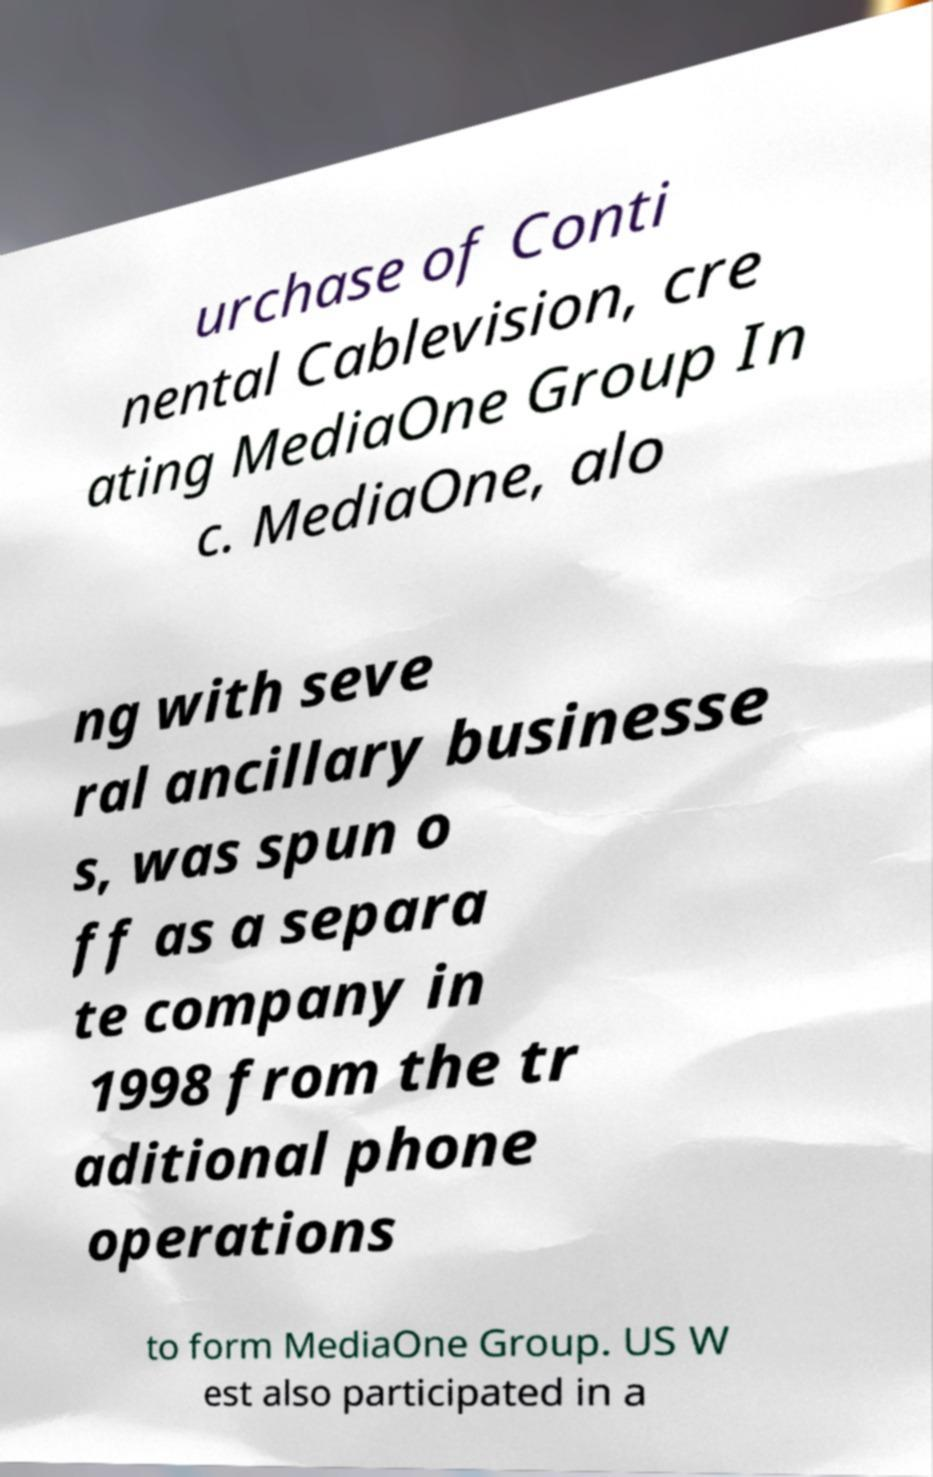Could you extract and type out the text from this image? urchase of Conti nental Cablevision, cre ating MediaOne Group In c. MediaOne, alo ng with seve ral ancillary businesse s, was spun o ff as a separa te company in 1998 from the tr aditional phone operations to form MediaOne Group. US W est also participated in a 